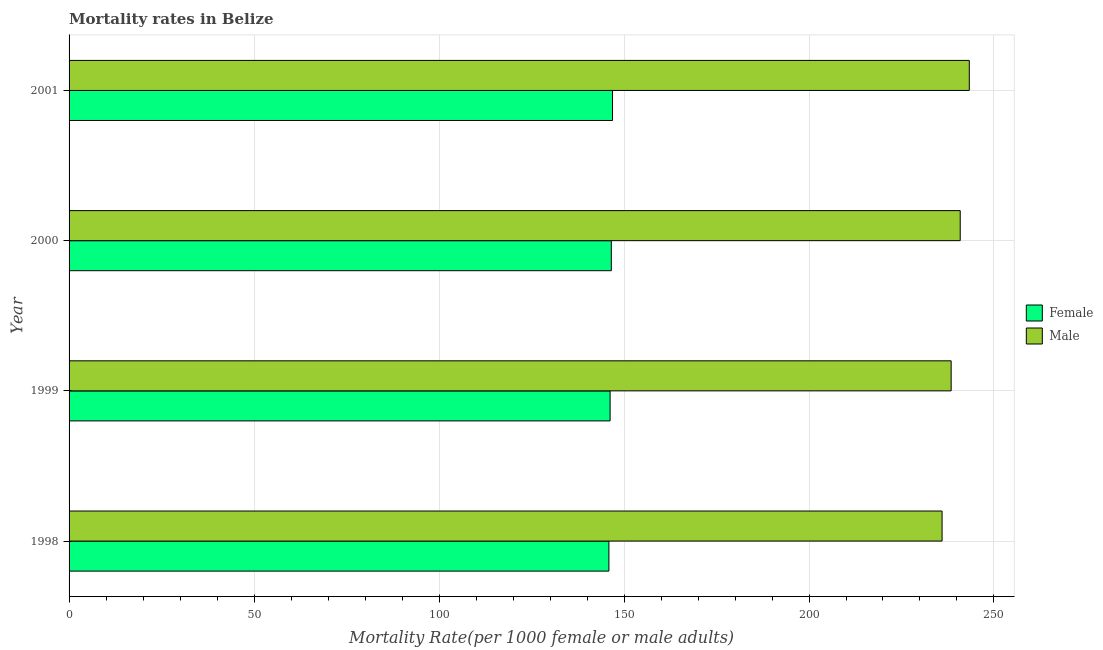How many different coloured bars are there?
Offer a terse response. 2. Are the number of bars per tick equal to the number of legend labels?
Keep it short and to the point. Yes. How many bars are there on the 1st tick from the top?
Offer a terse response. 2. How many bars are there on the 2nd tick from the bottom?
Offer a terse response. 2. What is the label of the 2nd group of bars from the top?
Make the answer very short. 2000. What is the male mortality rate in 2000?
Give a very brief answer. 240.88. Across all years, what is the maximum female mortality rate?
Provide a short and direct response. 146.89. Across all years, what is the minimum male mortality rate?
Your answer should be compact. 235.97. In which year was the female mortality rate maximum?
Your answer should be compact. 2001. In which year was the female mortality rate minimum?
Your answer should be very brief. 1998. What is the total male mortality rate in the graph?
Give a very brief answer. 958.6. What is the difference between the female mortality rate in 1999 and that in 2000?
Your answer should be compact. -0.33. What is the difference between the female mortality rate in 2001 and the male mortality rate in 2000?
Ensure brevity in your answer.  -93.98. What is the average female mortality rate per year?
Make the answer very short. 146.41. In the year 1998, what is the difference between the male mortality rate and female mortality rate?
Keep it short and to the point. 90.06. In how many years, is the female mortality rate greater than 220 ?
Offer a terse response. 0. Is the male mortality rate in 1998 less than that in 1999?
Provide a succinct answer. Yes. What is the difference between the highest and the second highest female mortality rate?
Ensure brevity in your answer.  0.33. Is the sum of the female mortality rate in 1999 and 2000 greater than the maximum male mortality rate across all years?
Make the answer very short. Yes. What does the 1st bar from the top in 2000 represents?
Offer a terse response. Male. How many years are there in the graph?
Keep it short and to the point. 4. Are the values on the major ticks of X-axis written in scientific E-notation?
Ensure brevity in your answer.  No. Does the graph contain grids?
Keep it short and to the point. Yes. Where does the legend appear in the graph?
Offer a very short reply. Center right. How many legend labels are there?
Make the answer very short. 2. How are the legend labels stacked?
Your answer should be very brief. Vertical. What is the title of the graph?
Provide a succinct answer. Mortality rates in Belize. What is the label or title of the X-axis?
Provide a short and direct response. Mortality Rate(per 1000 female or male adults). What is the label or title of the Y-axis?
Provide a short and direct response. Year. What is the Mortality Rate(per 1000 female or male adults) of Female in 1998?
Give a very brief answer. 145.92. What is the Mortality Rate(per 1000 female or male adults) of Male in 1998?
Give a very brief answer. 235.97. What is the Mortality Rate(per 1000 female or male adults) of Female in 1999?
Make the answer very short. 146.24. What is the Mortality Rate(per 1000 female or male adults) of Male in 1999?
Give a very brief answer. 238.42. What is the Mortality Rate(per 1000 female or male adults) of Female in 2000?
Your answer should be compact. 146.57. What is the Mortality Rate(per 1000 female or male adults) of Male in 2000?
Ensure brevity in your answer.  240.88. What is the Mortality Rate(per 1000 female or male adults) in Female in 2001?
Make the answer very short. 146.89. What is the Mortality Rate(per 1000 female or male adults) in Male in 2001?
Give a very brief answer. 243.33. Across all years, what is the maximum Mortality Rate(per 1000 female or male adults) in Female?
Your answer should be very brief. 146.89. Across all years, what is the maximum Mortality Rate(per 1000 female or male adults) in Male?
Ensure brevity in your answer.  243.33. Across all years, what is the minimum Mortality Rate(per 1000 female or male adults) of Female?
Your answer should be very brief. 145.92. Across all years, what is the minimum Mortality Rate(per 1000 female or male adults) in Male?
Give a very brief answer. 235.97. What is the total Mortality Rate(per 1000 female or male adults) of Female in the graph?
Offer a terse response. 585.62. What is the total Mortality Rate(per 1000 female or male adults) of Male in the graph?
Offer a very short reply. 958.6. What is the difference between the Mortality Rate(per 1000 female or male adults) of Female in 1998 and that in 1999?
Your answer should be very brief. -0.33. What is the difference between the Mortality Rate(per 1000 female or male adults) of Male in 1998 and that in 1999?
Your response must be concise. -2.45. What is the difference between the Mortality Rate(per 1000 female or male adults) of Female in 1998 and that in 2000?
Keep it short and to the point. -0.65. What is the difference between the Mortality Rate(per 1000 female or male adults) of Male in 1998 and that in 2000?
Ensure brevity in your answer.  -4.9. What is the difference between the Mortality Rate(per 1000 female or male adults) in Female in 1998 and that in 2001?
Offer a very short reply. -0.98. What is the difference between the Mortality Rate(per 1000 female or male adults) of Male in 1998 and that in 2001?
Your response must be concise. -7.36. What is the difference between the Mortality Rate(per 1000 female or male adults) in Female in 1999 and that in 2000?
Make the answer very short. -0.33. What is the difference between the Mortality Rate(per 1000 female or male adults) of Male in 1999 and that in 2000?
Offer a terse response. -2.45. What is the difference between the Mortality Rate(per 1000 female or male adults) of Female in 1999 and that in 2001?
Give a very brief answer. -0.65. What is the difference between the Mortality Rate(per 1000 female or male adults) of Male in 1999 and that in 2001?
Ensure brevity in your answer.  -4.9. What is the difference between the Mortality Rate(per 1000 female or male adults) in Female in 2000 and that in 2001?
Your answer should be very brief. -0.33. What is the difference between the Mortality Rate(per 1000 female or male adults) of Male in 2000 and that in 2001?
Provide a short and direct response. -2.45. What is the difference between the Mortality Rate(per 1000 female or male adults) of Female in 1998 and the Mortality Rate(per 1000 female or male adults) of Male in 1999?
Your response must be concise. -92.51. What is the difference between the Mortality Rate(per 1000 female or male adults) of Female in 1998 and the Mortality Rate(per 1000 female or male adults) of Male in 2000?
Make the answer very short. -94.96. What is the difference between the Mortality Rate(per 1000 female or male adults) in Female in 1998 and the Mortality Rate(per 1000 female or male adults) in Male in 2001?
Give a very brief answer. -97.41. What is the difference between the Mortality Rate(per 1000 female or male adults) in Female in 1999 and the Mortality Rate(per 1000 female or male adults) in Male in 2000?
Provide a succinct answer. -94.63. What is the difference between the Mortality Rate(per 1000 female or male adults) of Female in 1999 and the Mortality Rate(per 1000 female or male adults) of Male in 2001?
Give a very brief answer. -97.09. What is the difference between the Mortality Rate(per 1000 female or male adults) in Female in 2000 and the Mortality Rate(per 1000 female or male adults) in Male in 2001?
Your answer should be compact. -96.76. What is the average Mortality Rate(per 1000 female or male adults) in Female per year?
Your answer should be compact. 146.41. What is the average Mortality Rate(per 1000 female or male adults) of Male per year?
Make the answer very short. 239.65. In the year 1998, what is the difference between the Mortality Rate(per 1000 female or male adults) of Female and Mortality Rate(per 1000 female or male adults) of Male?
Provide a short and direct response. -90.06. In the year 1999, what is the difference between the Mortality Rate(per 1000 female or male adults) of Female and Mortality Rate(per 1000 female or male adults) of Male?
Provide a short and direct response. -92.18. In the year 2000, what is the difference between the Mortality Rate(per 1000 female or male adults) of Female and Mortality Rate(per 1000 female or male adults) of Male?
Make the answer very short. -94.31. In the year 2001, what is the difference between the Mortality Rate(per 1000 female or male adults) of Female and Mortality Rate(per 1000 female or male adults) of Male?
Make the answer very short. -96.43. What is the ratio of the Mortality Rate(per 1000 female or male adults) in Male in 1998 to that in 2000?
Provide a succinct answer. 0.98. What is the ratio of the Mortality Rate(per 1000 female or male adults) in Male in 1998 to that in 2001?
Your response must be concise. 0.97. What is the ratio of the Mortality Rate(per 1000 female or male adults) in Male in 1999 to that in 2000?
Offer a terse response. 0.99. What is the ratio of the Mortality Rate(per 1000 female or male adults) in Male in 1999 to that in 2001?
Ensure brevity in your answer.  0.98. What is the difference between the highest and the second highest Mortality Rate(per 1000 female or male adults) in Female?
Your response must be concise. 0.33. What is the difference between the highest and the second highest Mortality Rate(per 1000 female or male adults) in Male?
Your answer should be compact. 2.45. What is the difference between the highest and the lowest Mortality Rate(per 1000 female or male adults) in Male?
Your answer should be compact. 7.36. 